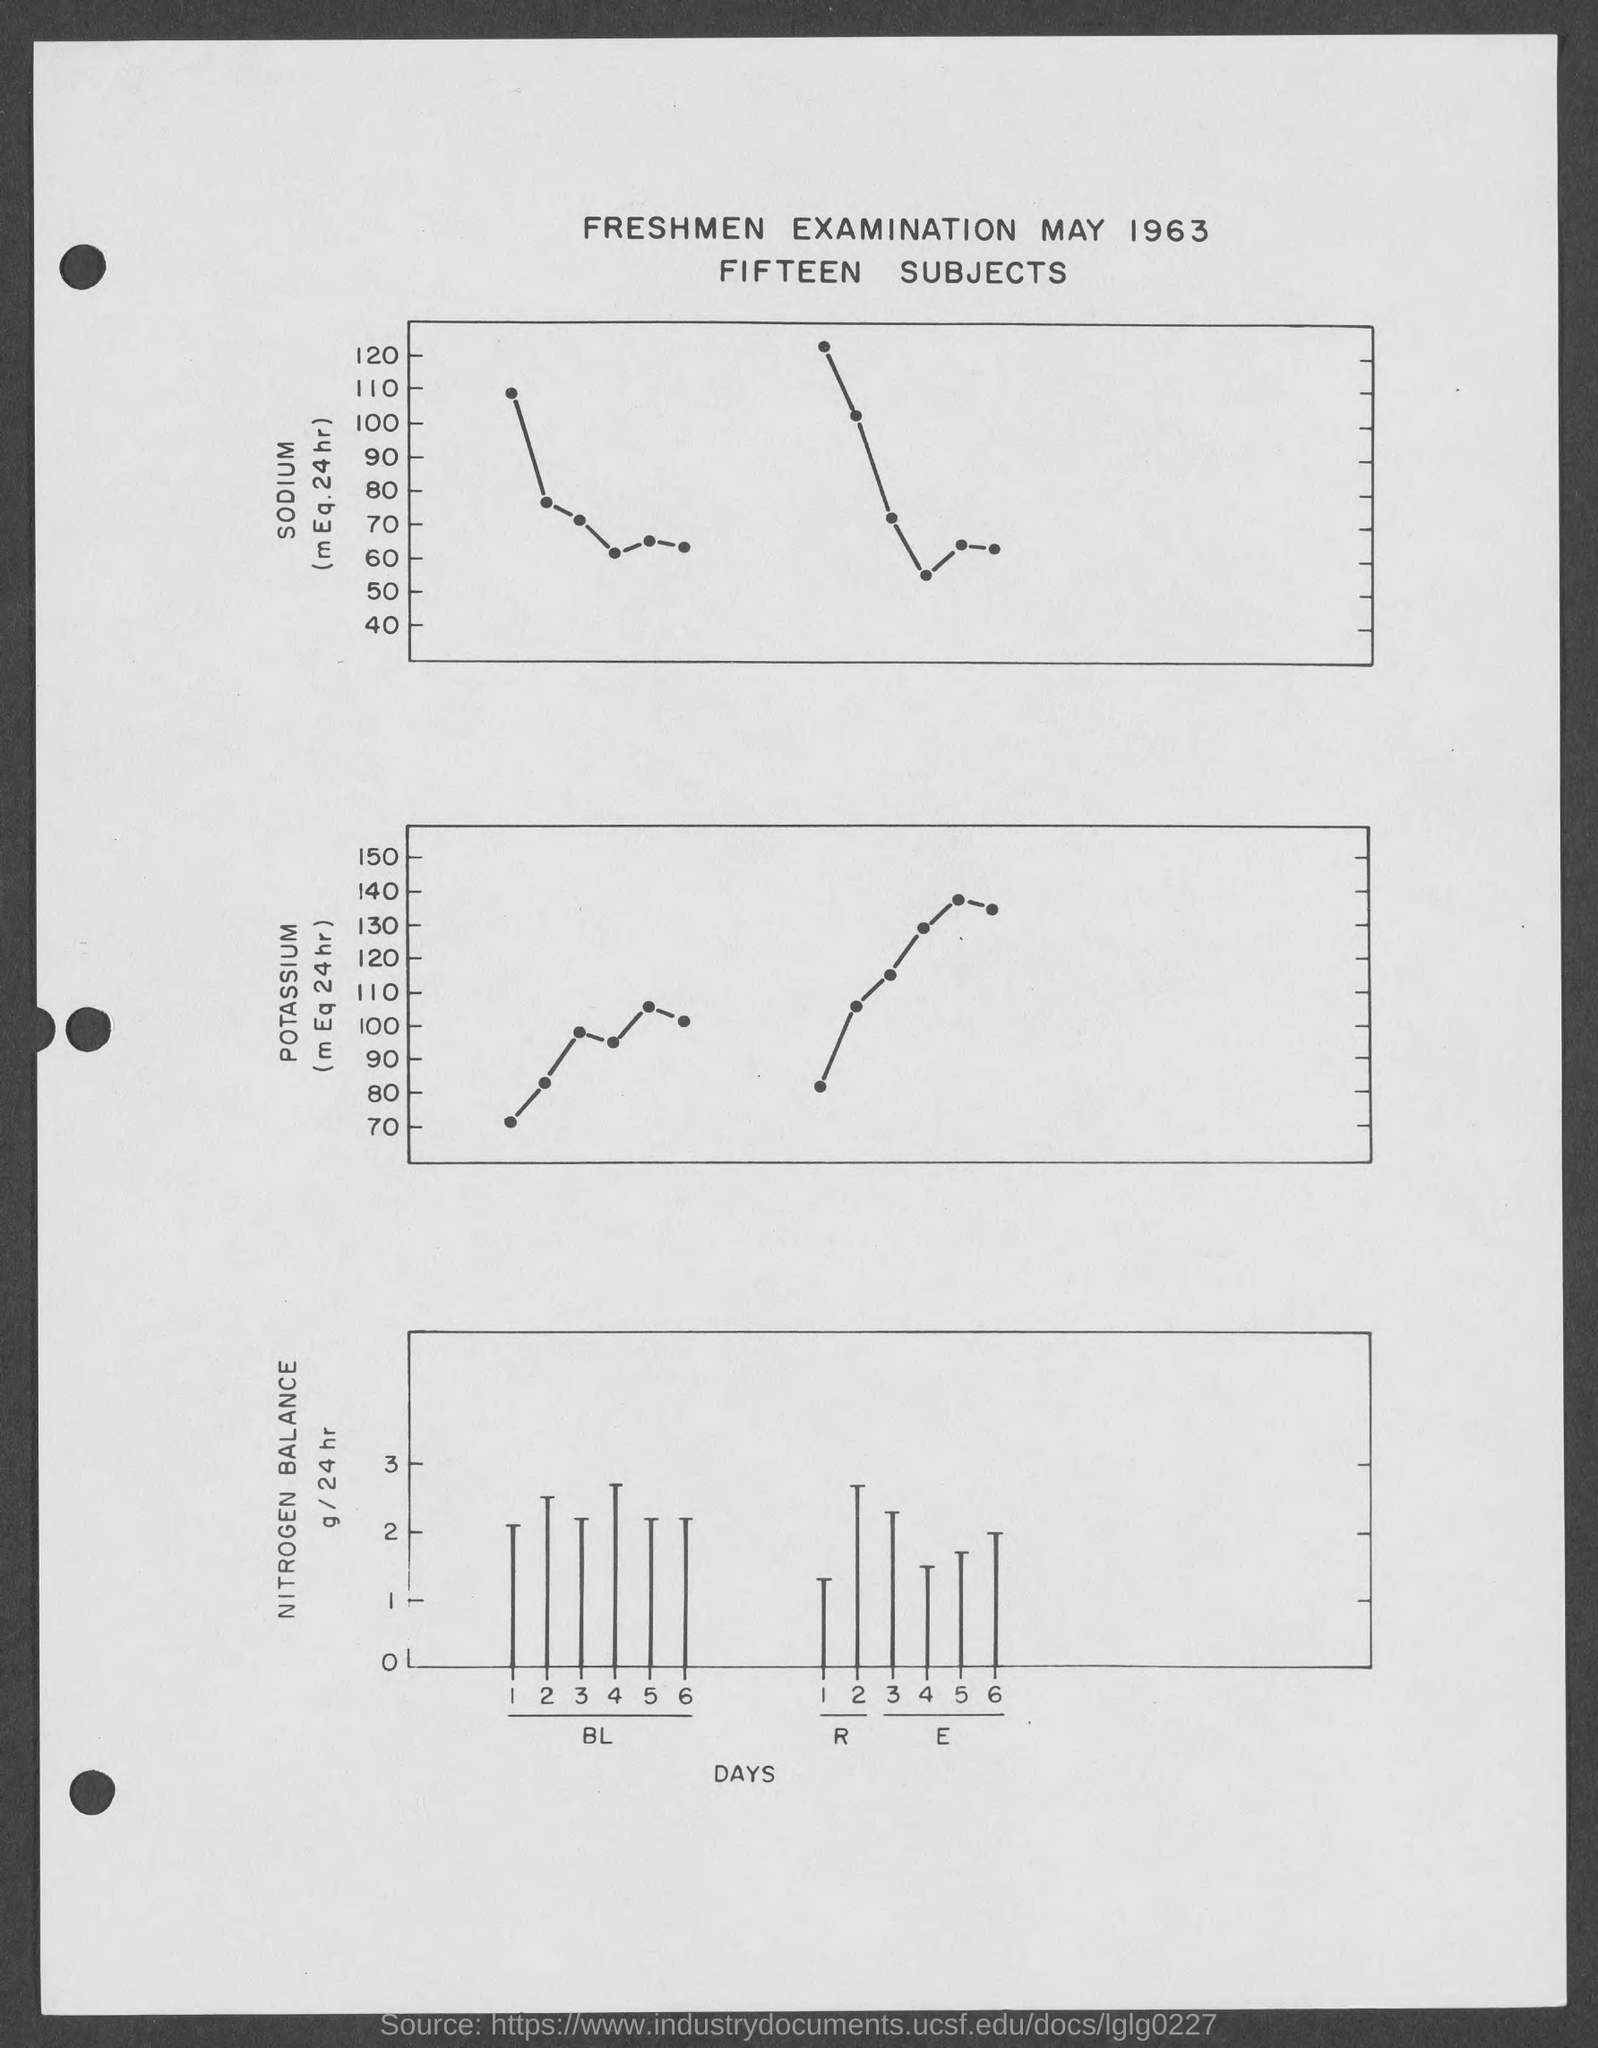List a handful of essential elements in this visual. What is the month mentioned in the given form? May. The given page contains 15 subjects. The year mentioned in the given form is 1963. 